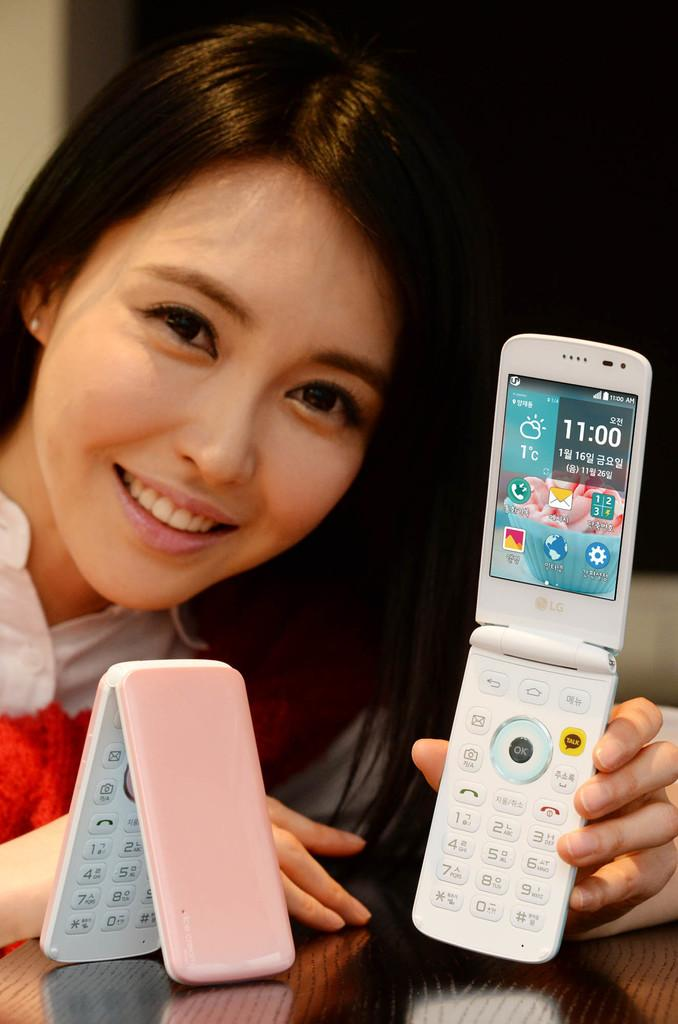<image>
Render a clear and concise summary of the photo. The lady is holding a white cell phone showing the time as 11:00. 